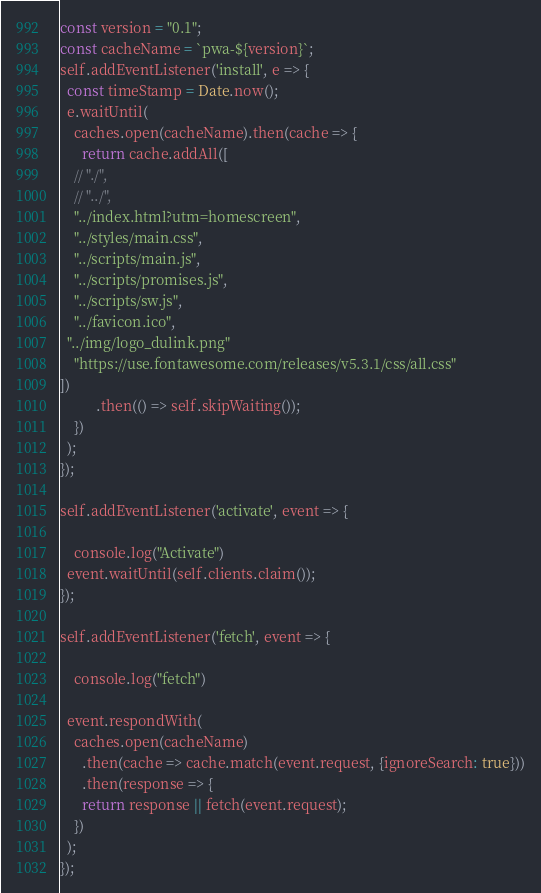Convert code to text. <code><loc_0><loc_0><loc_500><loc_500><_JavaScript_>const version = "0.1";
const cacheName = `pwa-${version}`;
self.addEventListener('install', e => {
  const timeStamp = Date.now();
  e.waitUntil(
    caches.open(cacheName).then(cache => {
      return cache.addAll([
	// "./",
	// "../",
	"../index.html?utm=homescreen",
	"../styles/main.css",
	"../scripts/main.js",
	"../scripts/promises.js",
	"../scripts/sw.js",
	"../favicon.ico",
  "../img/logo_dulink.png"
	"https://use.fontawesome.com/releases/v5.3.1/css/all.css"
])
          .then(() => self.skipWaiting());
    })
  );
});

self.addEventListener('activate', event => {

	console.log("Activate")
  event.waitUntil(self.clients.claim());
});

self.addEventListener('fetch', event => {

	console.log("fetch")

  event.respondWith(
    caches.open(cacheName)
      .then(cache => cache.match(event.request, {ignoreSearch: true}))
      .then(response => {
      return response || fetch(event.request);
    })
  );
});
</code> 